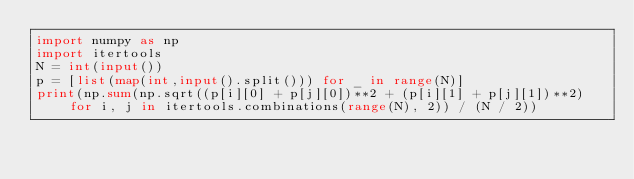<code> <loc_0><loc_0><loc_500><loc_500><_Python_>import numpy as np
import itertools
N = int(input())
p = [list(map(int,input().split())) for _ in range(N)]
print(np.sum(np.sqrt((p[i][0] + p[j][0])**2 + (p[i][1] + p[j][1])**2) for i, j in itertools.combinations(range(N), 2)) / (N / 2))</code> 